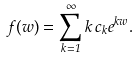<formula> <loc_0><loc_0><loc_500><loc_500>f ( w ) = \sum _ { k = 1 } ^ { \infty } k \, c _ { k } e ^ { k w } .</formula> 